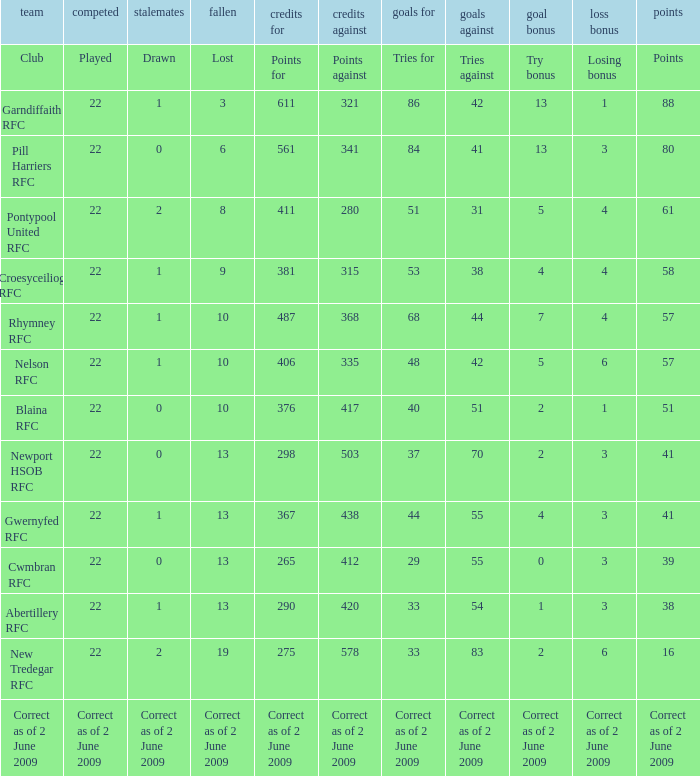How many points against did the club with a losing bonus of 3 and 84 tries have? 341.0. 